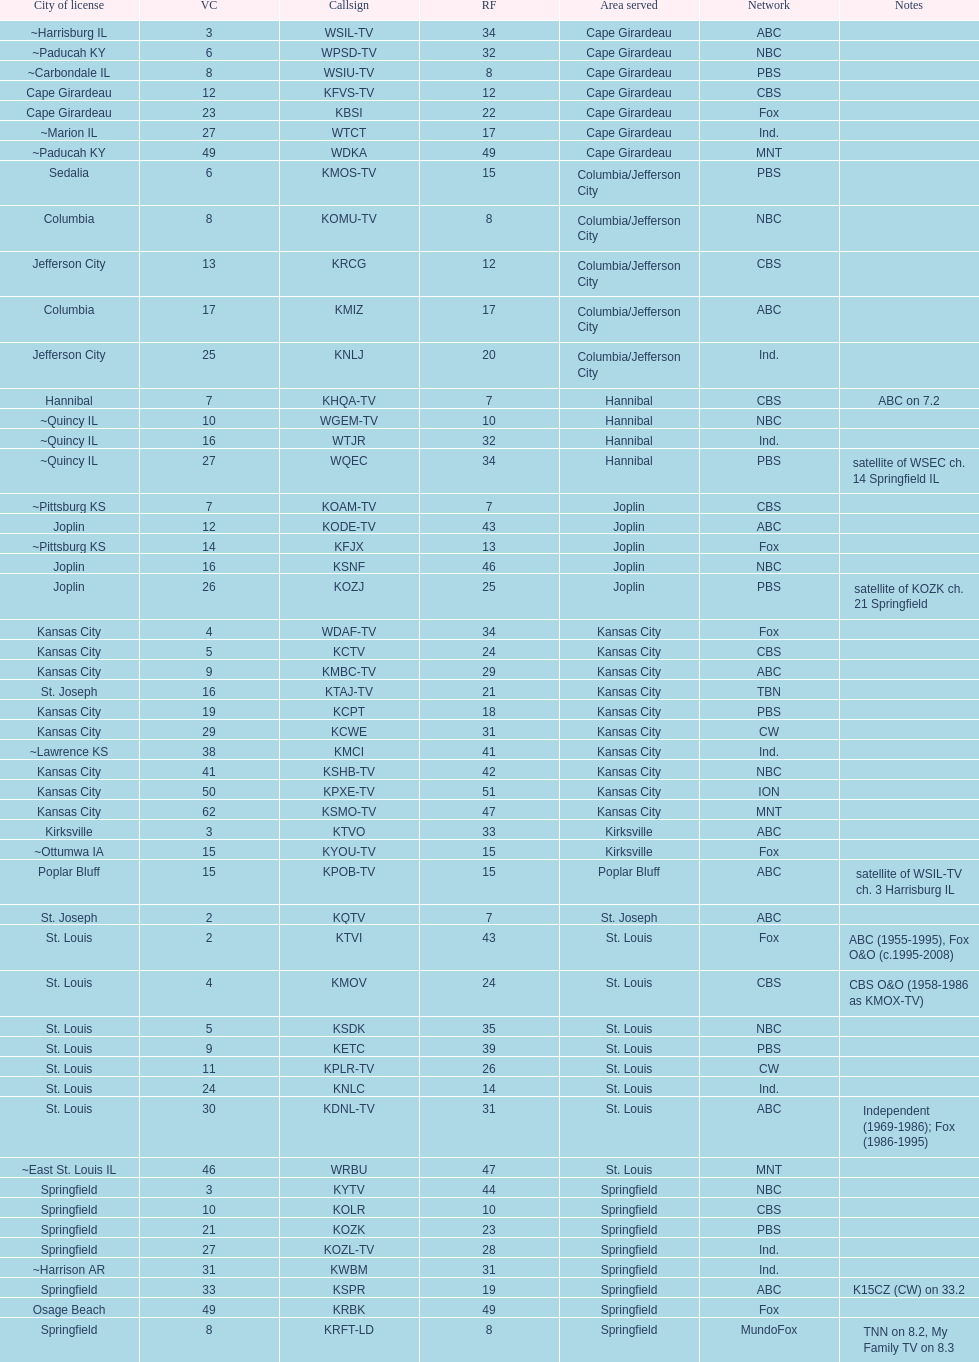What is the total number of stations under the cbs network? 7. 